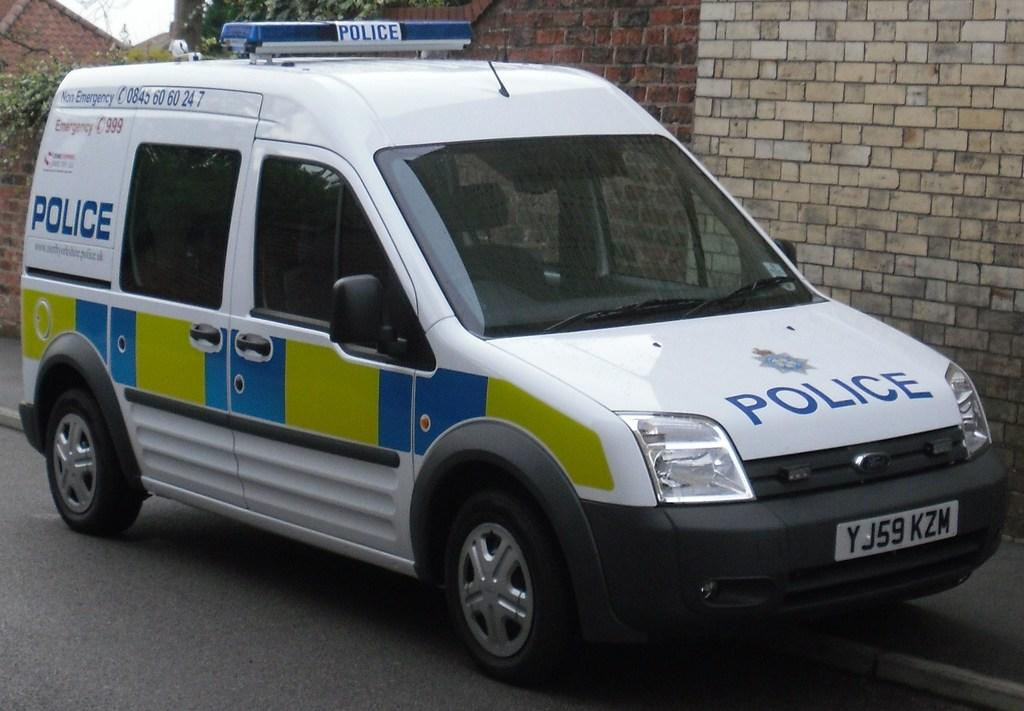Provide a one-sentence caption for the provided image. A white, blue and green police van is parked on a street. 